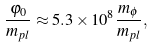Convert formula to latex. <formula><loc_0><loc_0><loc_500><loc_500>\frac { \varphi _ { 0 } } { m _ { p l } } \approx 5 . 3 \times 1 0 ^ { 8 } \frac { m _ { \phi } } { m _ { p l } } ,</formula> 